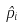<formula> <loc_0><loc_0><loc_500><loc_500>\hat { p } _ { i }</formula> 